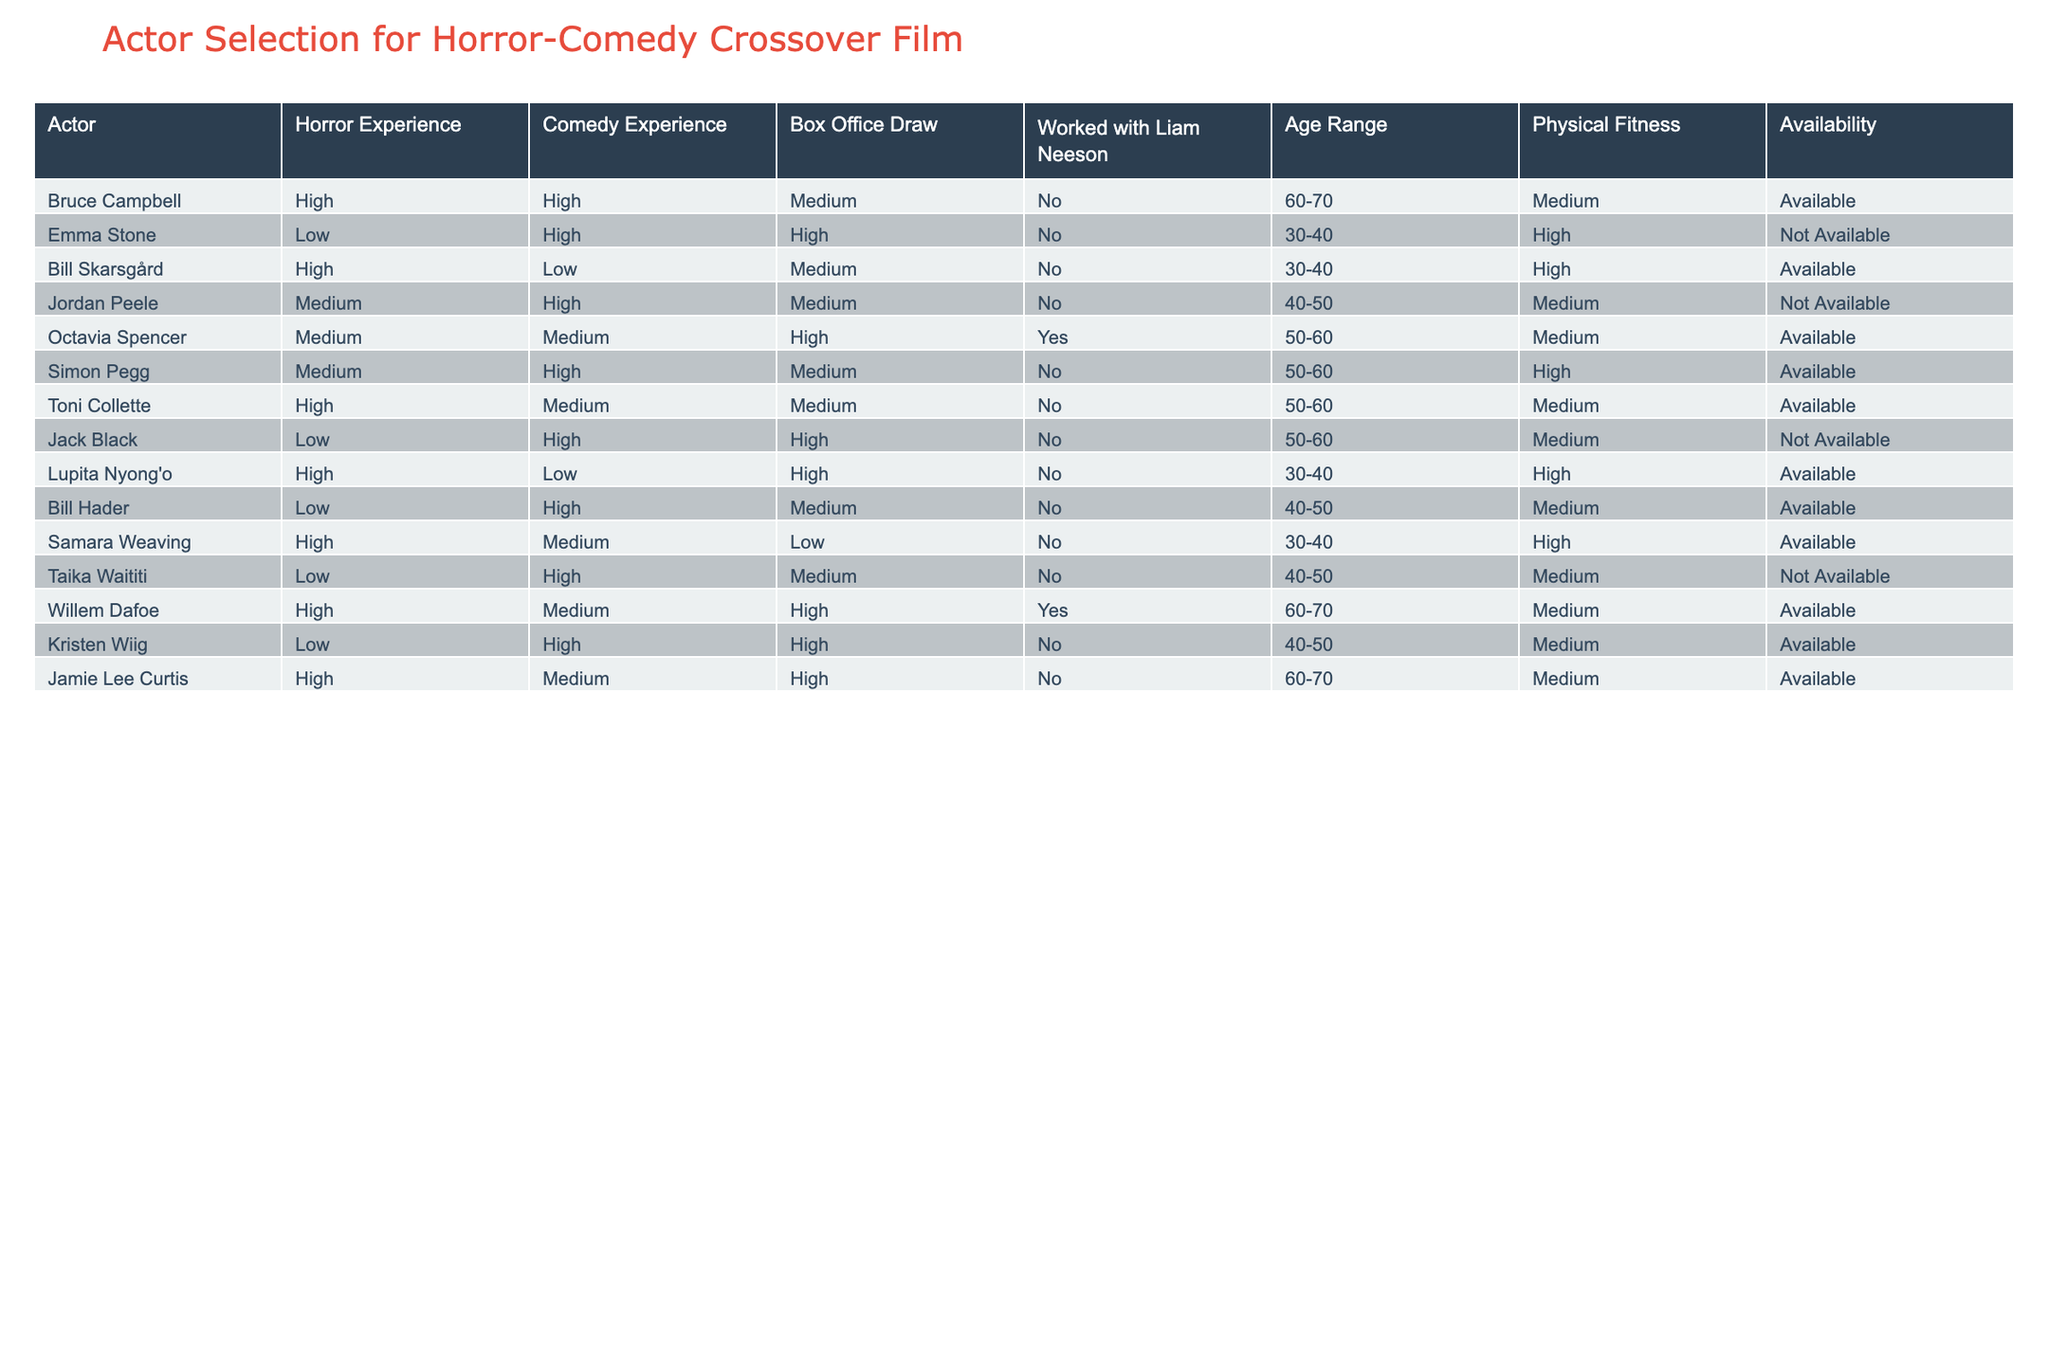What is the horror experience level of Bruce Campbell? Bruce Campbell's horror experience level is listed as 'High' in the table.
Answer: High Which actor has worked with Liam Neeson and has medium physical fitness? The table indicates that Octavia Spencer and Willem Dafoe both worked with Liam Neeson and have medium physical fitness.
Answer: Octavia Spencer, Willem Dafoe What is the age range of Emma Stone? From the table, Emma Stone's age range is noted as '30-40'.
Answer: 30-40 Is Jack Black available for the film? The table shows that Jack Black is 'Not Available' for the film.
Answer: No How many actors have high comedy experience? By examining the table, actors with high comedy experience include: Emma Stone, Jordan Peele, Jack Black, Simon Pegg, Bill Hader, Kristen Wiig, and Octavia Spencer (a total of 7 actors).
Answer: 7 Which actor is the youngest and has high physical fitness? The youngest actors listed with high physical fitness are Emma Stone and Lupita Nyong'o, both in the age range of '30-40'.
Answer: Emma Stone, Lupita Nyong'o What is the average age range of actors with high horror experience? The actors with high horror experience are Bruce Campbell, Bill Skarsgård, Toni Collette, Willem Dafoe, Jamie Lee Curtis, and Lupita Nyong'o. Their ages can be averaged as follows: (65 + 35 + 55 + 65 + 65 + 35)/6 = 52.5, which can be represented as the age range of 50-60.
Answer: 50-60 Are there any actors available who have both medium horror and medium comedy experience? From the table, Toni Collette and Octavia Spencer have medium horror and medium comedy experiences and are available for the film.
Answer: Yes Which actor with the highest box office draw has horror experience? Emma Stone has high box office draw and low horror experience, while Willem Dafoe has high box office draw and high horror experience, making him the actor with the highest box office draw having horror experience.
Answer: Willem Dafoe 